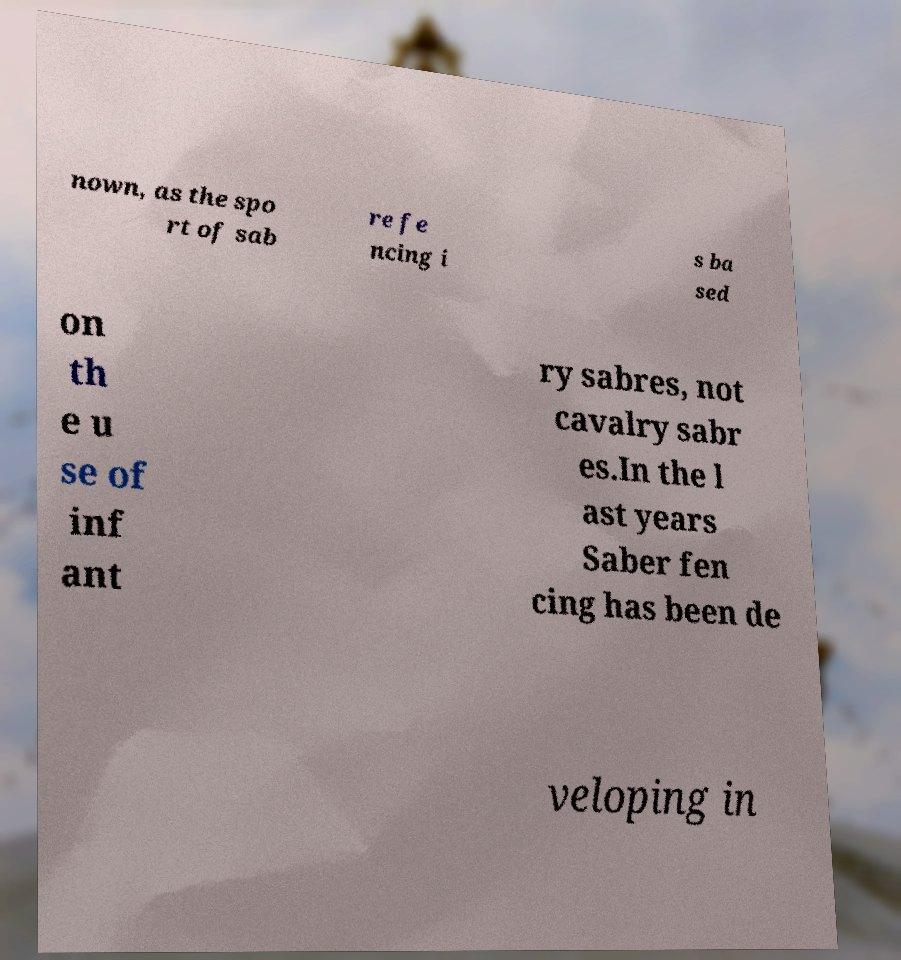Can you read and provide the text displayed in the image?This photo seems to have some interesting text. Can you extract and type it out for me? nown, as the spo rt of sab re fe ncing i s ba sed on th e u se of inf ant ry sabres, not cavalry sabr es.In the l ast years Saber fen cing has been de veloping in 